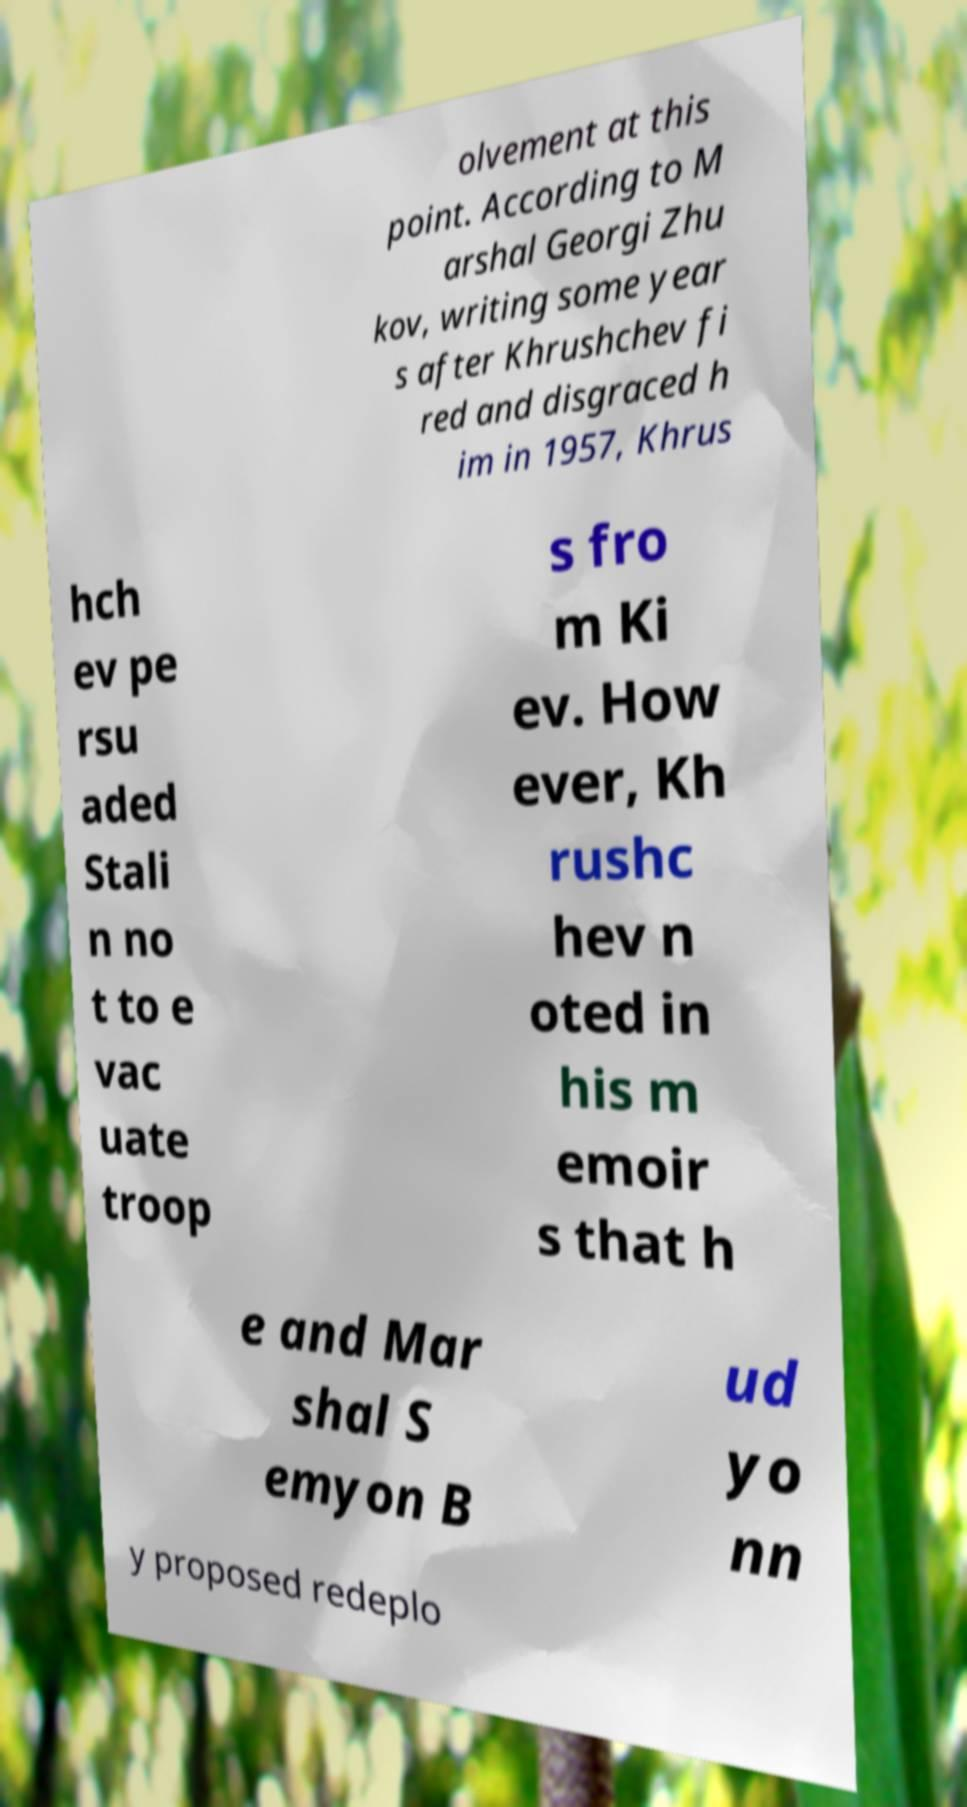Could you assist in decoding the text presented in this image and type it out clearly? olvement at this point. According to M arshal Georgi Zhu kov, writing some year s after Khrushchev fi red and disgraced h im in 1957, Khrus hch ev pe rsu aded Stali n no t to e vac uate troop s fro m Ki ev. How ever, Kh rushc hev n oted in his m emoir s that h e and Mar shal S emyon B ud yo nn y proposed redeplo 